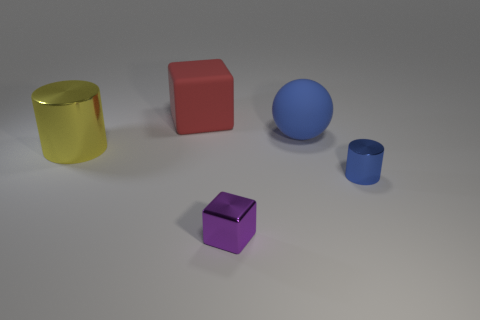What is the size of the rubber object that is the same color as the tiny metal cylinder?
Your answer should be very brief. Large. What is the size of the blue object that is behind the small metallic thing right of the purple thing?
Provide a succinct answer. Large. There is a big cube that is the same material as the blue ball; what is its color?
Give a very brief answer. Red. Are there fewer tiny blue objects than small red matte cylinders?
Your response must be concise. No. What is the object that is both to the left of the blue shiny cylinder and in front of the big cylinder made of?
Offer a terse response. Metal. Are there any things that are behind the purple metallic cube left of the ball?
Offer a terse response. Yes. How many metal cylinders are the same color as the rubber sphere?
Provide a short and direct response. 1. There is a thing that is the same color as the sphere; what is it made of?
Your answer should be very brief. Metal. Is the material of the small purple block the same as the yellow thing?
Provide a succinct answer. Yes. There is a large blue sphere; are there any tiny blue metal objects in front of it?
Offer a terse response. Yes. 